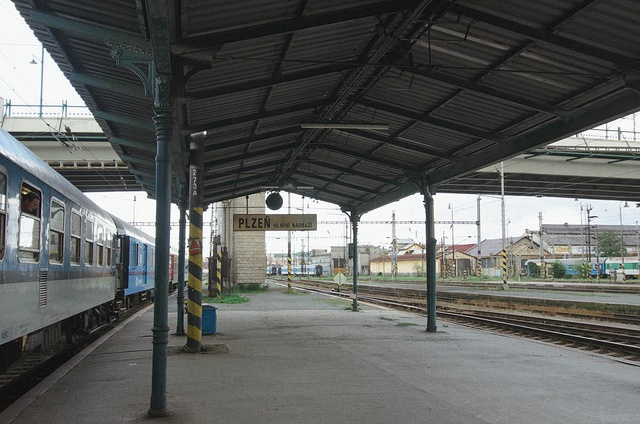Describe the objects in this image and their specific colors. I can see train in white, gray, black, darkgray, and lightgray tones and people in white, black, maroon, and gray tones in this image. 